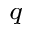<formula> <loc_0><loc_0><loc_500><loc_500>_ { q }</formula> 